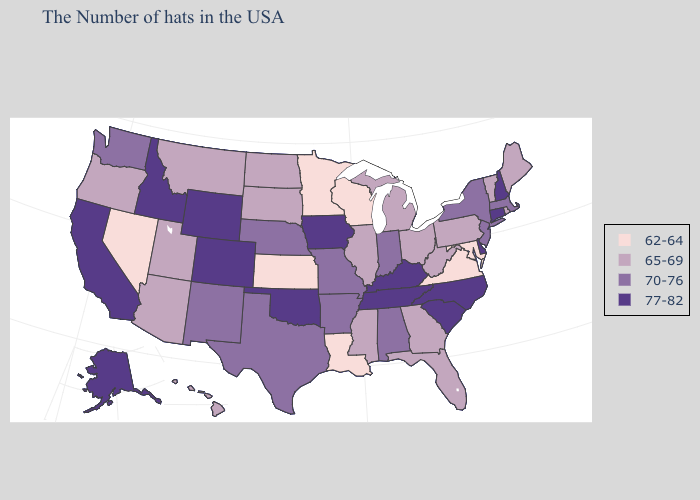Does Utah have the lowest value in the West?
Write a very short answer. No. What is the highest value in the MidWest ?
Keep it brief. 77-82. Name the states that have a value in the range 77-82?
Keep it brief. New Hampshire, Connecticut, Delaware, North Carolina, South Carolina, Kentucky, Tennessee, Iowa, Oklahoma, Wyoming, Colorado, Idaho, California, Alaska. What is the highest value in the USA?
Concise answer only. 77-82. What is the lowest value in states that border West Virginia?
Be succinct. 62-64. What is the value of Hawaii?
Short answer required. 65-69. What is the highest value in states that border Colorado?
Be succinct. 77-82. Name the states that have a value in the range 65-69?
Keep it brief. Maine, Rhode Island, Vermont, Pennsylvania, West Virginia, Ohio, Florida, Georgia, Michigan, Illinois, Mississippi, South Dakota, North Dakota, Utah, Montana, Arizona, Oregon, Hawaii. What is the highest value in states that border South Carolina?
Be succinct. 77-82. What is the value of Wisconsin?
Quick response, please. 62-64. Does Louisiana have the lowest value in the USA?
Keep it brief. Yes. What is the lowest value in states that border New Hampshire?
Write a very short answer. 65-69. Does Tennessee have the highest value in the South?
Quick response, please. Yes. Name the states that have a value in the range 77-82?
Concise answer only. New Hampshire, Connecticut, Delaware, North Carolina, South Carolina, Kentucky, Tennessee, Iowa, Oklahoma, Wyoming, Colorado, Idaho, California, Alaska. What is the value of South Carolina?
Short answer required. 77-82. 